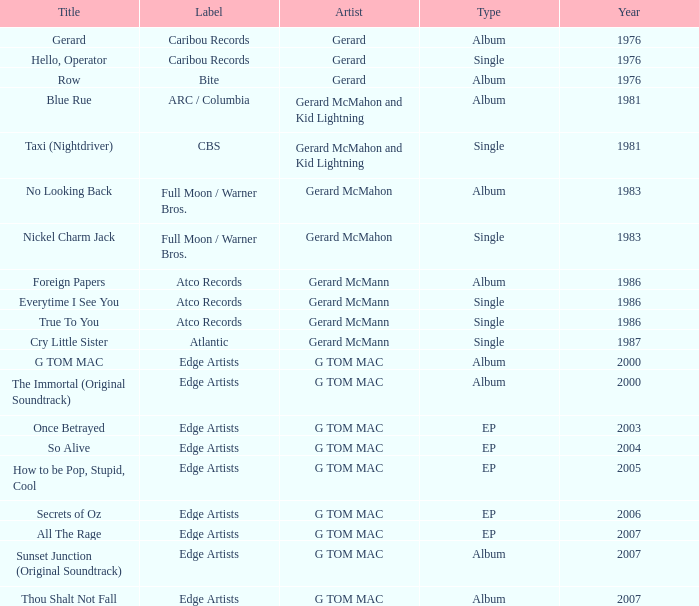Which Title has a Type of album in 1983? No Looking Back. 